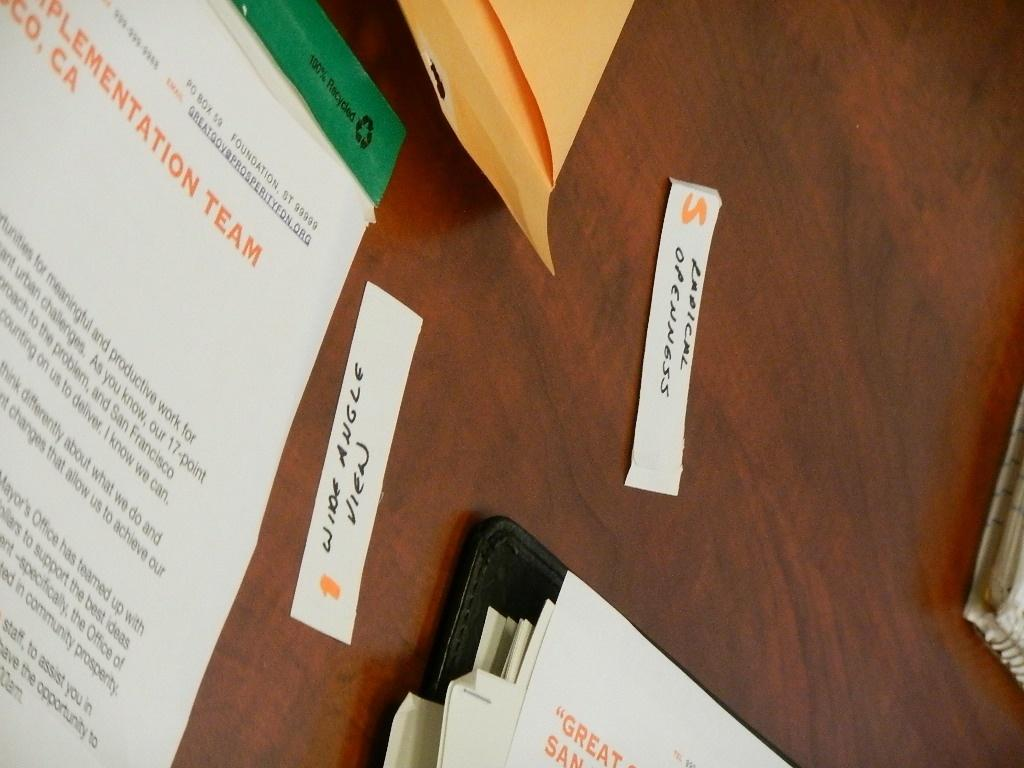<image>
Describe the image concisely. Slips of paper sit on the bale with papers for greatgove@prosperityfdn.org 